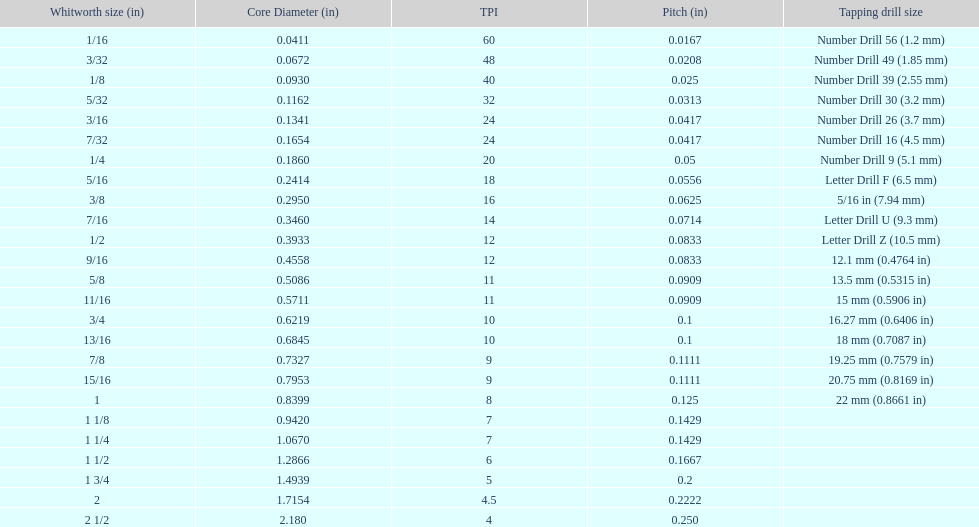What is the total of the first two core diameters? 0.1083. 